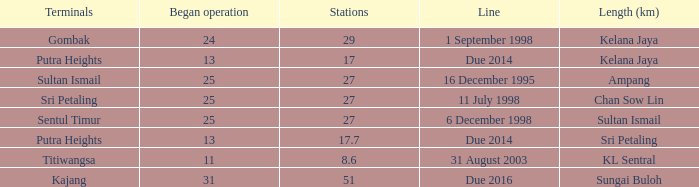What is the average operation beginning with a length of ampang and over 27 stations? None. 